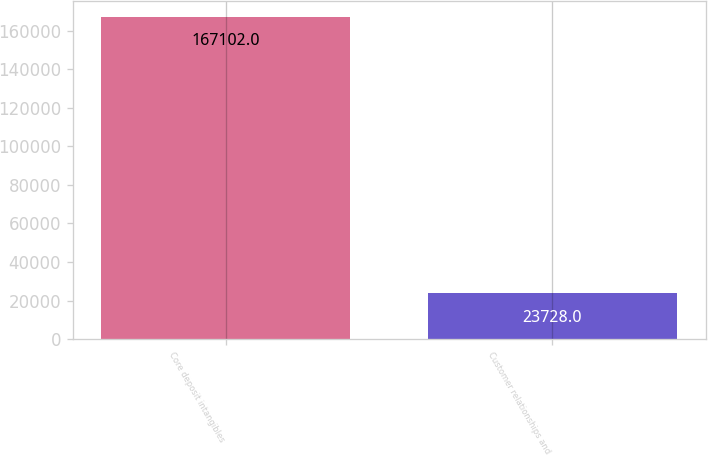<chart> <loc_0><loc_0><loc_500><loc_500><bar_chart><fcel>Core deposit intangibles<fcel>Customer relationships and<nl><fcel>167102<fcel>23728<nl></chart> 